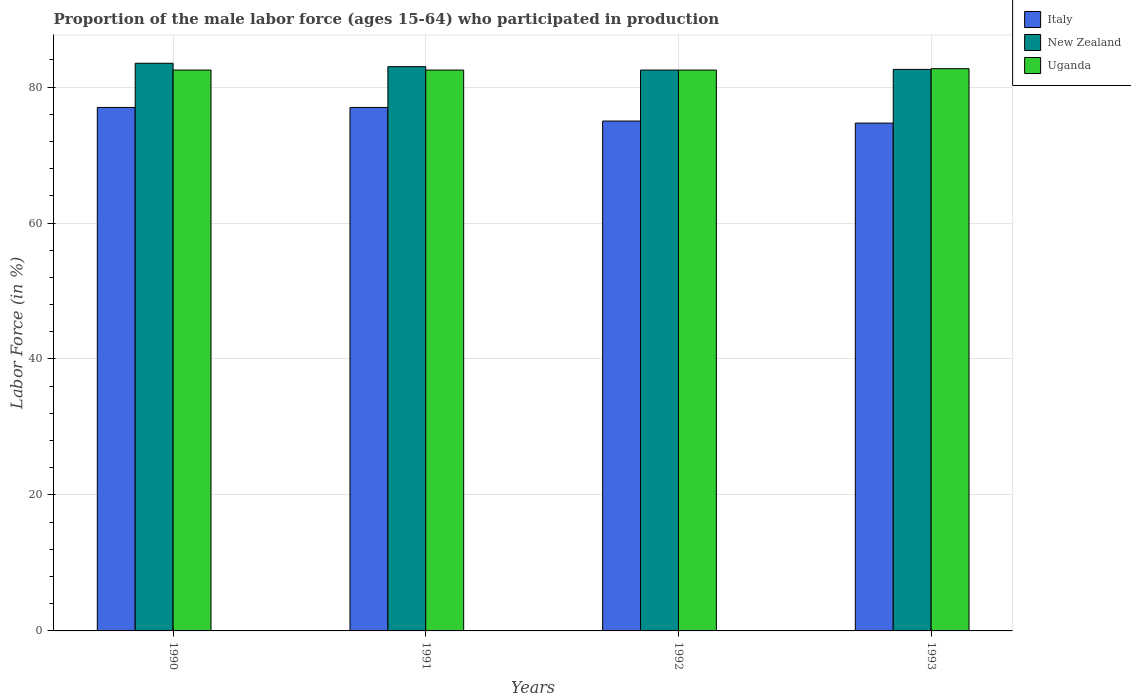How many different coloured bars are there?
Provide a succinct answer. 3. Are the number of bars per tick equal to the number of legend labels?
Offer a terse response. Yes. Are the number of bars on each tick of the X-axis equal?
Your answer should be very brief. Yes. How many bars are there on the 2nd tick from the right?
Offer a terse response. 3. In how many cases, is the number of bars for a given year not equal to the number of legend labels?
Ensure brevity in your answer.  0. What is the proportion of the male labor force who participated in production in Uganda in 1991?
Offer a terse response. 82.5. Across all years, what is the maximum proportion of the male labor force who participated in production in Italy?
Your answer should be very brief. 77. Across all years, what is the minimum proportion of the male labor force who participated in production in Italy?
Offer a terse response. 74.7. In which year was the proportion of the male labor force who participated in production in Uganda maximum?
Make the answer very short. 1993. What is the total proportion of the male labor force who participated in production in Uganda in the graph?
Make the answer very short. 330.2. What is the difference between the proportion of the male labor force who participated in production in New Zealand in 1991 and that in 1992?
Ensure brevity in your answer.  0.5. What is the difference between the proportion of the male labor force who participated in production in Uganda in 1993 and the proportion of the male labor force who participated in production in New Zealand in 1990?
Offer a very short reply. -0.8. What is the average proportion of the male labor force who participated in production in Italy per year?
Your response must be concise. 75.92. In the year 1991, what is the difference between the proportion of the male labor force who participated in production in Italy and proportion of the male labor force who participated in production in Uganda?
Keep it short and to the point. -5.5. Is the proportion of the male labor force who participated in production in Uganda in 1991 less than that in 1993?
Ensure brevity in your answer.  Yes. Is the difference between the proportion of the male labor force who participated in production in Italy in 1990 and 1992 greater than the difference between the proportion of the male labor force who participated in production in Uganda in 1990 and 1992?
Your answer should be very brief. Yes. What is the difference between the highest and the lowest proportion of the male labor force who participated in production in Italy?
Make the answer very short. 2.3. In how many years, is the proportion of the male labor force who participated in production in Uganda greater than the average proportion of the male labor force who participated in production in Uganda taken over all years?
Your response must be concise. 1. What does the 2nd bar from the left in 1990 represents?
Make the answer very short. New Zealand. What does the 1st bar from the right in 1990 represents?
Keep it short and to the point. Uganda. Is it the case that in every year, the sum of the proportion of the male labor force who participated in production in New Zealand and proportion of the male labor force who participated in production in Italy is greater than the proportion of the male labor force who participated in production in Uganda?
Your answer should be very brief. Yes. How many years are there in the graph?
Provide a succinct answer. 4. What is the difference between two consecutive major ticks on the Y-axis?
Offer a terse response. 20. Does the graph contain any zero values?
Offer a terse response. No. Where does the legend appear in the graph?
Make the answer very short. Top right. How many legend labels are there?
Keep it short and to the point. 3. How are the legend labels stacked?
Ensure brevity in your answer.  Vertical. What is the title of the graph?
Your answer should be compact. Proportion of the male labor force (ages 15-64) who participated in production. Does "Benin" appear as one of the legend labels in the graph?
Give a very brief answer. No. What is the Labor Force (in %) of New Zealand in 1990?
Provide a succinct answer. 83.5. What is the Labor Force (in %) of Uganda in 1990?
Keep it short and to the point. 82.5. What is the Labor Force (in %) of New Zealand in 1991?
Keep it short and to the point. 83. What is the Labor Force (in %) in Uganda in 1991?
Give a very brief answer. 82.5. What is the Labor Force (in %) in New Zealand in 1992?
Your answer should be compact. 82.5. What is the Labor Force (in %) in Uganda in 1992?
Provide a succinct answer. 82.5. What is the Labor Force (in %) of Italy in 1993?
Make the answer very short. 74.7. What is the Labor Force (in %) in New Zealand in 1993?
Offer a terse response. 82.6. What is the Labor Force (in %) of Uganda in 1993?
Offer a terse response. 82.7. Across all years, what is the maximum Labor Force (in %) of Italy?
Your response must be concise. 77. Across all years, what is the maximum Labor Force (in %) in New Zealand?
Offer a very short reply. 83.5. Across all years, what is the maximum Labor Force (in %) in Uganda?
Offer a very short reply. 82.7. Across all years, what is the minimum Labor Force (in %) of Italy?
Keep it short and to the point. 74.7. Across all years, what is the minimum Labor Force (in %) in New Zealand?
Offer a terse response. 82.5. Across all years, what is the minimum Labor Force (in %) in Uganda?
Offer a terse response. 82.5. What is the total Labor Force (in %) of Italy in the graph?
Make the answer very short. 303.7. What is the total Labor Force (in %) in New Zealand in the graph?
Offer a very short reply. 331.6. What is the total Labor Force (in %) in Uganda in the graph?
Give a very brief answer. 330.2. What is the difference between the Labor Force (in %) of Italy in 1990 and that in 1991?
Offer a very short reply. 0. What is the difference between the Labor Force (in %) in Uganda in 1990 and that in 1991?
Make the answer very short. 0. What is the difference between the Labor Force (in %) of Italy in 1990 and that in 1992?
Offer a very short reply. 2. What is the difference between the Labor Force (in %) in Uganda in 1990 and that in 1992?
Ensure brevity in your answer.  0. What is the difference between the Labor Force (in %) in Uganda in 1990 and that in 1993?
Give a very brief answer. -0.2. What is the difference between the Labor Force (in %) of New Zealand in 1991 and that in 1992?
Provide a short and direct response. 0.5. What is the difference between the Labor Force (in %) of Uganda in 1991 and that in 1992?
Give a very brief answer. 0. What is the difference between the Labor Force (in %) of New Zealand in 1991 and that in 1993?
Provide a succinct answer. 0.4. What is the difference between the Labor Force (in %) in Uganda in 1991 and that in 1993?
Give a very brief answer. -0.2. What is the difference between the Labor Force (in %) of Italy in 1992 and that in 1993?
Offer a terse response. 0.3. What is the difference between the Labor Force (in %) in Uganda in 1992 and that in 1993?
Ensure brevity in your answer.  -0.2. What is the difference between the Labor Force (in %) of New Zealand in 1990 and the Labor Force (in %) of Uganda in 1991?
Give a very brief answer. 1. What is the difference between the Labor Force (in %) in Italy in 1990 and the Labor Force (in %) in New Zealand in 1993?
Your answer should be very brief. -5.6. What is the difference between the Labor Force (in %) of Italy in 1991 and the Labor Force (in %) of Uganda in 1992?
Provide a succinct answer. -5.5. What is the difference between the Labor Force (in %) of New Zealand in 1991 and the Labor Force (in %) of Uganda in 1992?
Your response must be concise. 0.5. What is the difference between the Labor Force (in %) in New Zealand in 1992 and the Labor Force (in %) in Uganda in 1993?
Keep it short and to the point. -0.2. What is the average Labor Force (in %) of Italy per year?
Your response must be concise. 75.92. What is the average Labor Force (in %) in New Zealand per year?
Provide a short and direct response. 82.9. What is the average Labor Force (in %) in Uganda per year?
Make the answer very short. 82.55. In the year 1990, what is the difference between the Labor Force (in %) of Italy and Labor Force (in %) of New Zealand?
Provide a short and direct response. -6.5. In the year 1990, what is the difference between the Labor Force (in %) in New Zealand and Labor Force (in %) in Uganda?
Provide a succinct answer. 1. In the year 1991, what is the difference between the Labor Force (in %) in Italy and Labor Force (in %) in Uganda?
Your answer should be very brief. -5.5. In the year 1991, what is the difference between the Labor Force (in %) in New Zealand and Labor Force (in %) in Uganda?
Your response must be concise. 0.5. In the year 1992, what is the difference between the Labor Force (in %) of New Zealand and Labor Force (in %) of Uganda?
Your answer should be compact. 0. In the year 1993, what is the difference between the Labor Force (in %) of Italy and Labor Force (in %) of New Zealand?
Offer a very short reply. -7.9. In the year 1993, what is the difference between the Labor Force (in %) of New Zealand and Labor Force (in %) of Uganda?
Provide a succinct answer. -0.1. What is the ratio of the Labor Force (in %) of Italy in 1990 to that in 1991?
Offer a terse response. 1. What is the ratio of the Labor Force (in %) in Italy in 1990 to that in 1992?
Ensure brevity in your answer.  1.03. What is the ratio of the Labor Force (in %) of New Zealand in 1990 to that in 1992?
Offer a terse response. 1.01. What is the ratio of the Labor Force (in %) in Italy in 1990 to that in 1993?
Provide a short and direct response. 1.03. What is the ratio of the Labor Force (in %) of New Zealand in 1990 to that in 1993?
Your response must be concise. 1.01. What is the ratio of the Labor Force (in %) in Italy in 1991 to that in 1992?
Provide a succinct answer. 1.03. What is the ratio of the Labor Force (in %) of Uganda in 1991 to that in 1992?
Provide a succinct answer. 1. What is the ratio of the Labor Force (in %) of Italy in 1991 to that in 1993?
Keep it short and to the point. 1.03. What is the ratio of the Labor Force (in %) of Uganda in 1991 to that in 1993?
Ensure brevity in your answer.  1. What is the ratio of the Labor Force (in %) of Italy in 1992 to that in 1993?
Your response must be concise. 1. What is the ratio of the Labor Force (in %) of New Zealand in 1992 to that in 1993?
Ensure brevity in your answer.  1. What is the ratio of the Labor Force (in %) in Uganda in 1992 to that in 1993?
Offer a terse response. 1. What is the difference between the highest and the second highest Labor Force (in %) of Italy?
Provide a succinct answer. 0. What is the difference between the highest and the second highest Labor Force (in %) of Uganda?
Ensure brevity in your answer.  0.2. What is the difference between the highest and the lowest Labor Force (in %) of Italy?
Your answer should be compact. 2.3. What is the difference between the highest and the lowest Labor Force (in %) of New Zealand?
Ensure brevity in your answer.  1. What is the difference between the highest and the lowest Labor Force (in %) of Uganda?
Your answer should be compact. 0.2. 